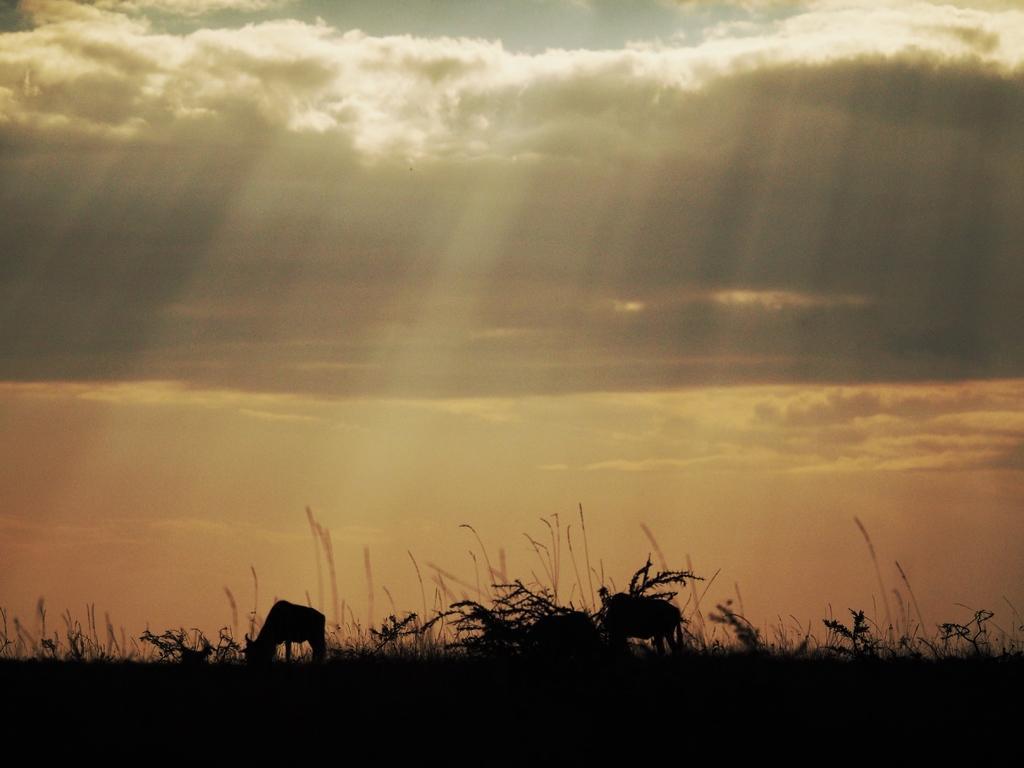What types of living organisms can be seen in the image? There are animals in the image. What type of vegetation is present in the image? There is grass in the image. What can be seen in the background of the image? The sky is visible in the background of the image. What type of paper can be seen in the image? There is no paper present in the image. 